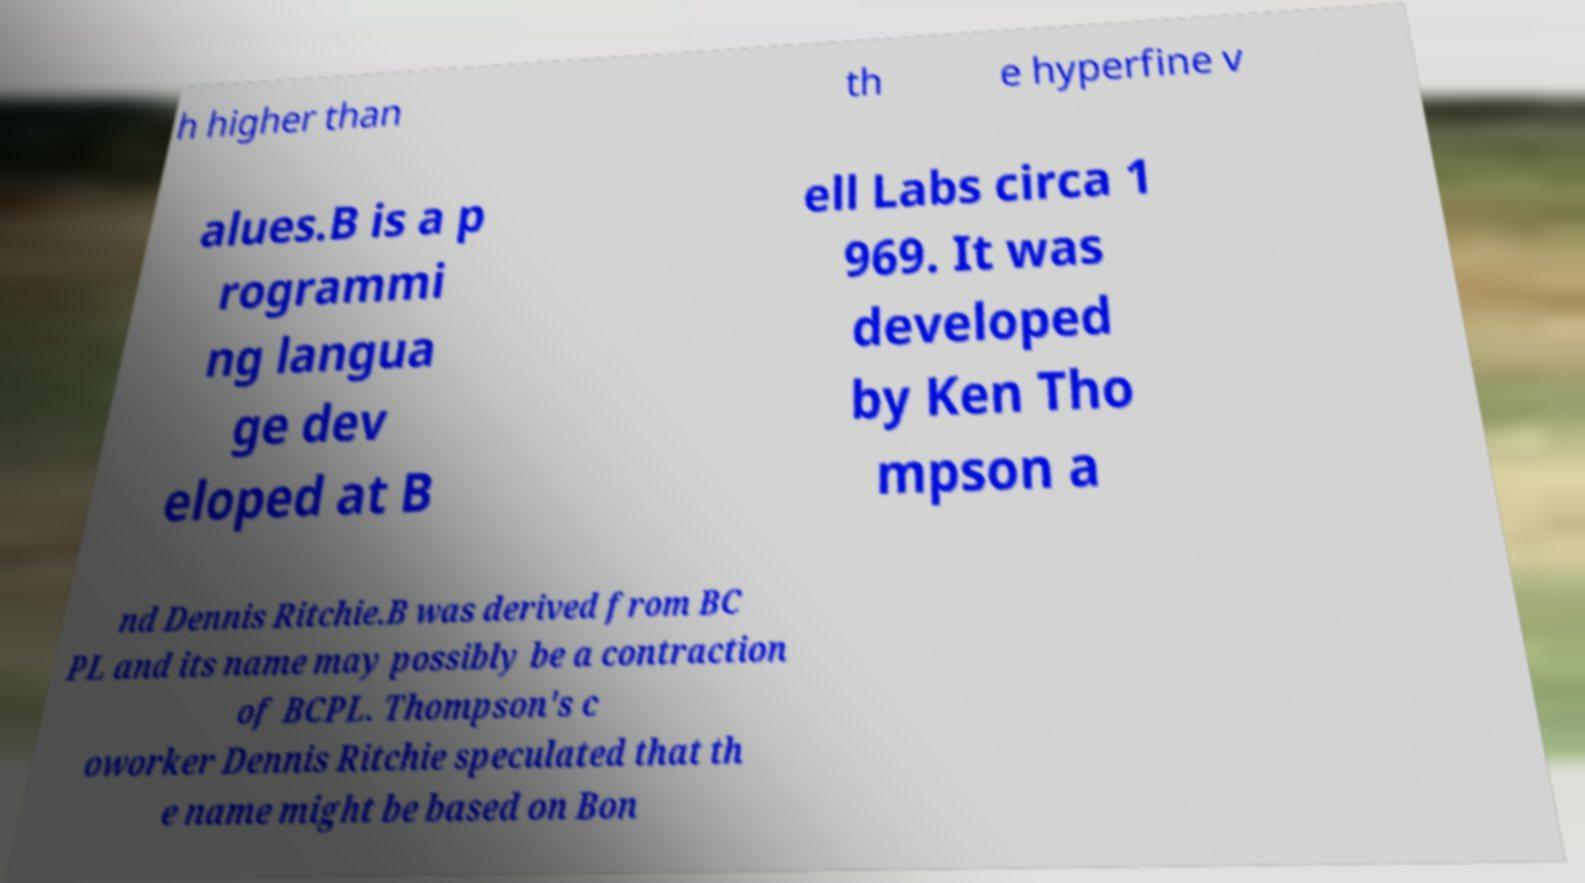What messages or text are displayed in this image? I need them in a readable, typed format. h higher than th e hyperfine v alues.B is a p rogrammi ng langua ge dev eloped at B ell Labs circa 1 969. It was developed by Ken Tho mpson a nd Dennis Ritchie.B was derived from BC PL and its name may possibly be a contraction of BCPL. Thompson's c oworker Dennis Ritchie speculated that th e name might be based on Bon 